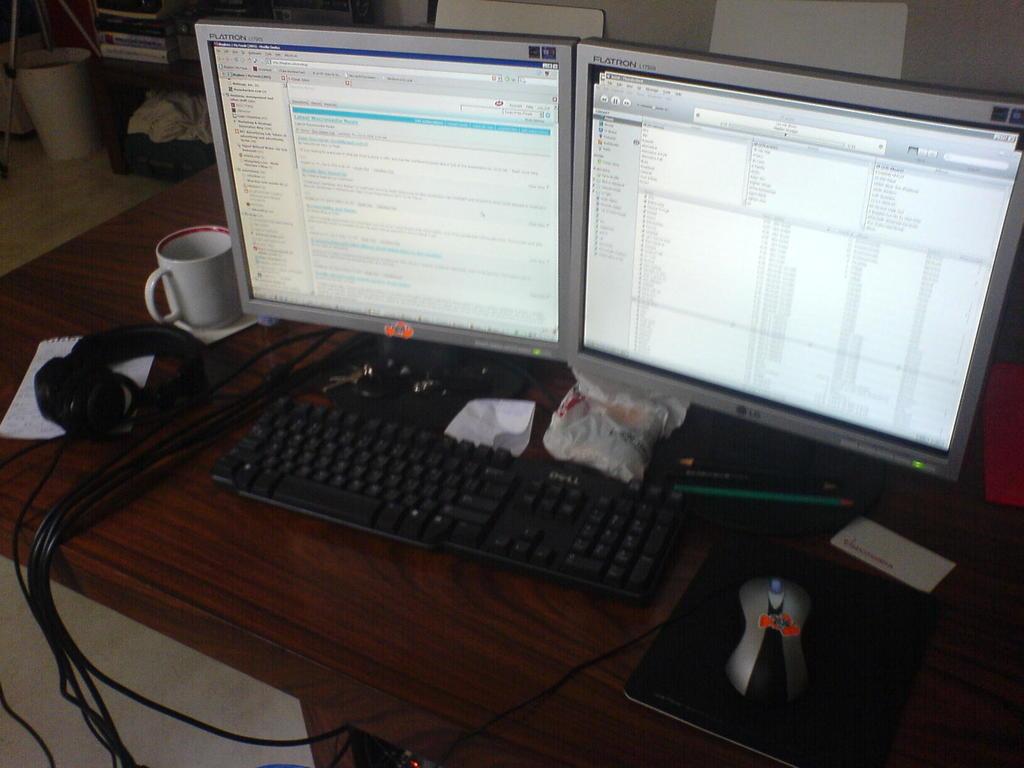What's the brand name of the right monitor?
Your answer should be very brief. Lg. What brand is the keyboard?
Offer a very short reply. Dell. 